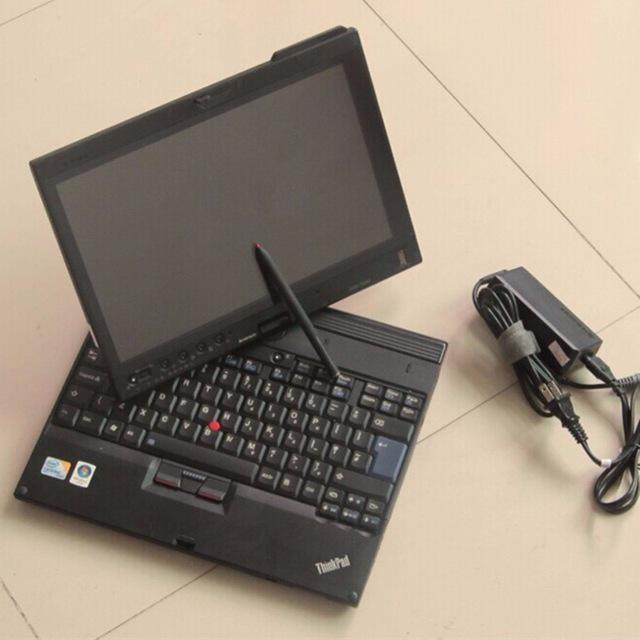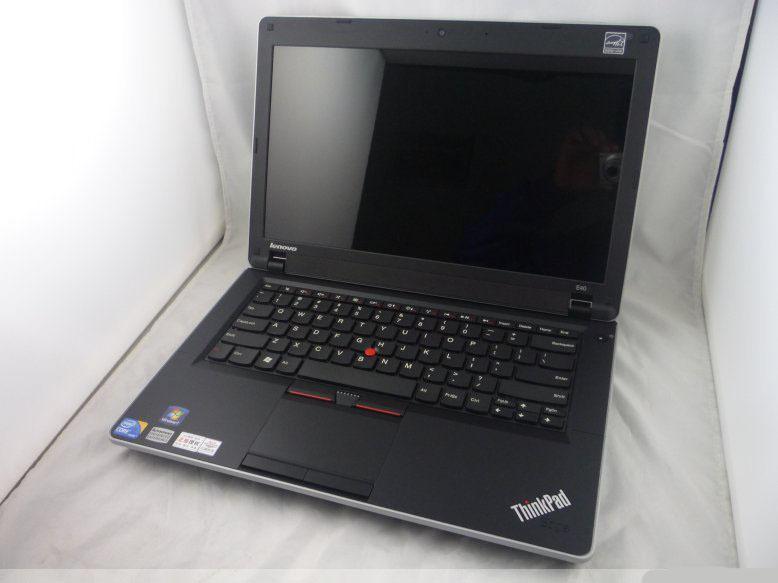The first image is the image on the left, the second image is the image on the right. For the images shown, is this caption "At least one image shows stacks of devices." true? Answer yes or no. No. The first image is the image on the left, the second image is the image on the right. Evaluate the accuracy of this statement regarding the images: "Some laptops are stacked in multiple rows at least four to a stack.". Is it true? Answer yes or no. No. 